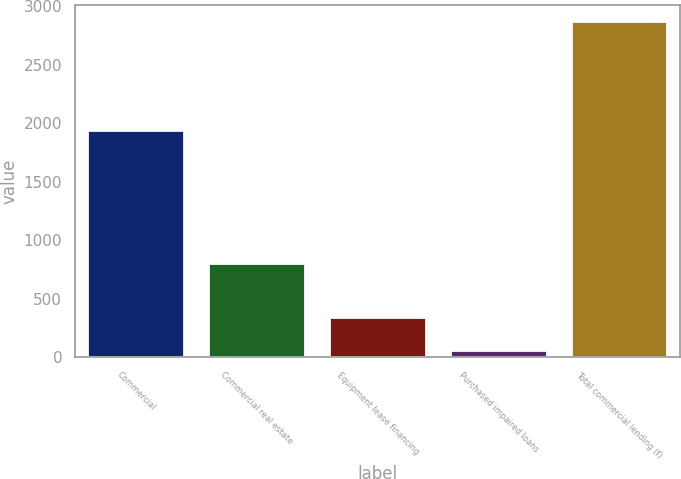Convert chart to OTSL. <chart><loc_0><loc_0><loc_500><loc_500><bar_chart><fcel>Commercial<fcel>Commercial real estate<fcel>Equipment lease financing<fcel>Purchased impaired loans<fcel>Total commercial lending (f)<nl><fcel>1939<fcel>804<fcel>341.1<fcel>60<fcel>2871<nl></chart> 